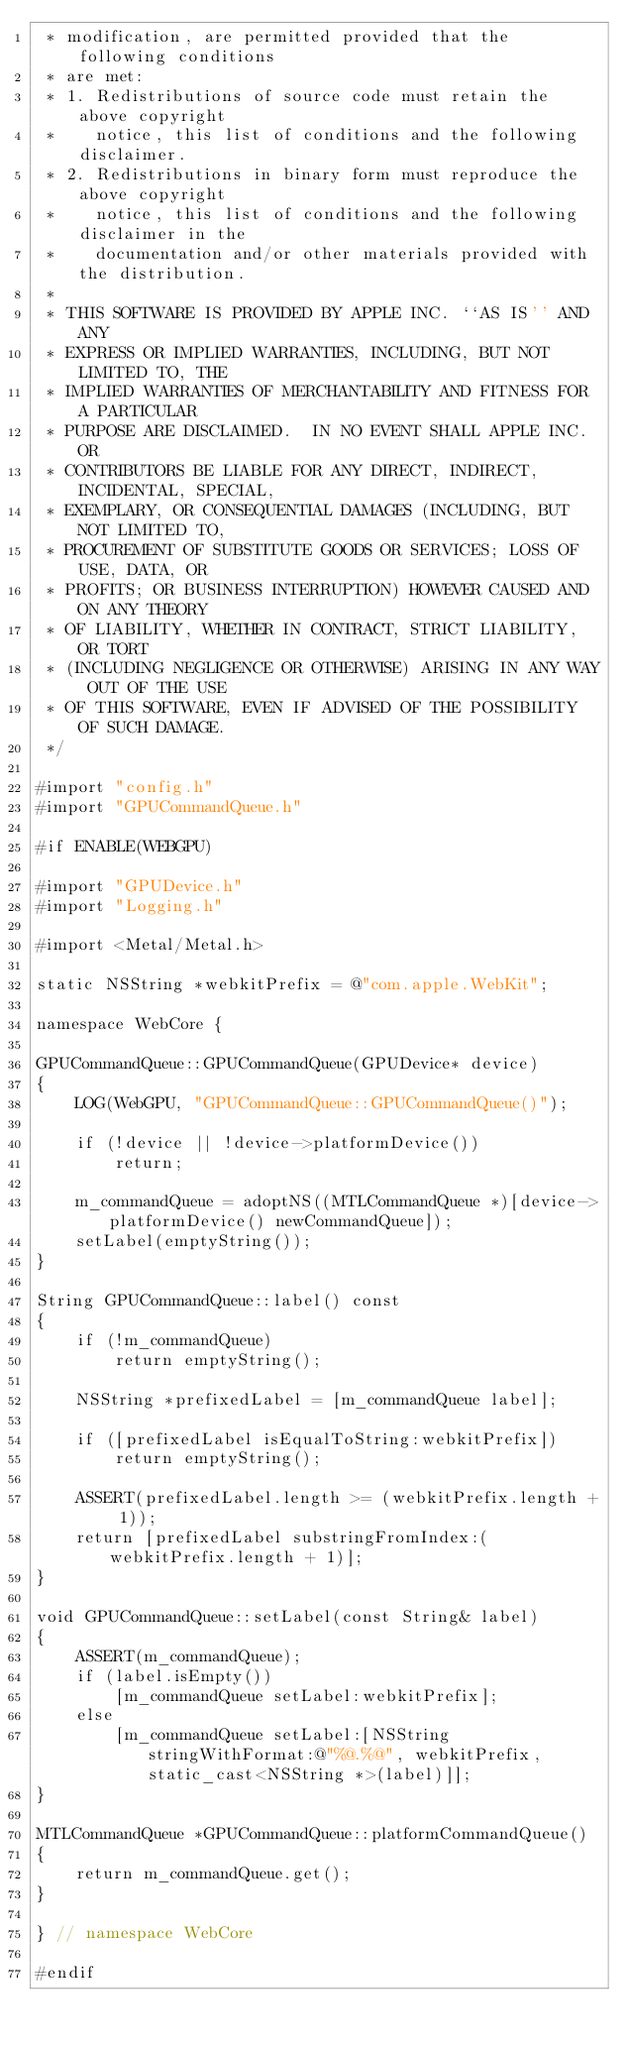<code> <loc_0><loc_0><loc_500><loc_500><_ObjectiveC_> * modification, are permitted provided that the following conditions
 * are met:
 * 1. Redistributions of source code must retain the above copyright
 *    notice, this list of conditions and the following disclaimer.
 * 2. Redistributions in binary form must reproduce the above copyright
 *    notice, this list of conditions and the following disclaimer in the
 *    documentation and/or other materials provided with the distribution.
 *
 * THIS SOFTWARE IS PROVIDED BY APPLE INC. ``AS IS'' AND ANY
 * EXPRESS OR IMPLIED WARRANTIES, INCLUDING, BUT NOT LIMITED TO, THE
 * IMPLIED WARRANTIES OF MERCHANTABILITY AND FITNESS FOR A PARTICULAR
 * PURPOSE ARE DISCLAIMED.  IN NO EVENT SHALL APPLE INC. OR
 * CONTRIBUTORS BE LIABLE FOR ANY DIRECT, INDIRECT, INCIDENTAL, SPECIAL,
 * EXEMPLARY, OR CONSEQUENTIAL DAMAGES (INCLUDING, BUT NOT LIMITED TO,
 * PROCUREMENT OF SUBSTITUTE GOODS OR SERVICES; LOSS OF USE, DATA, OR
 * PROFITS; OR BUSINESS INTERRUPTION) HOWEVER CAUSED AND ON ANY THEORY
 * OF LIABILITY, WHETHER IN CONTRACT, STRICT LIABILITY, OR TORT
 * (INCLUDING NEGLIGENCE OR OTHERWISE) ARISING IN ANY WAY OUT OF THE USE
 * OF THIS SOFTWARE, EVEN IF ADVISED OF THE POSSIBILITY OF SUCH DAMAGE.
 */

#import "config.h"
#import "GPUCommandQueue.h"

#if ENABLE(WEBGPU)

#import "GPUDevice.h"
#import "Logging.h"

#import <Metal/Metal.h>

static NSString *webkitPrefix = @"com.apple.WebKit";

namespace WebCore {

GPUCommandQueue::GPUCommandQueue(GPUDevice* device)
{
    LOG(WebGPU, "GPUCommandQueue::GPUCommandQueue()");

    if (!device || !device->platformDevice())
        return;

    m_commandQueue = adoptNS((MTLCommandQueue *)[device->platformDevice() newCommandQueue]);
    setLabel(emptyString());
}

String GPUCommandQueue::label() const
{
    if (!m_commandQueue)
        return emptyString();

    NSString *prefixedLabel = [m_commandQueue label];

    if ([prefixedLabel isEqualToString:webkitPrefix])
        return emptyString();

    ASSERT(prefixedLabel.length >= (webkitPrefix.length + 1));
    return [prefixedLabel substringFromIndex:(webkitPrefix.length + 1)];
}

void GPUCommandQueue::setLabel(const String& label)
{
    ASSERT(m_commandQueue);
    if (label.isEmpty())
        [m_commandQueue setLabel:webkitPrefix];
    else
        [m_commandQueue setLabel:[NSString stringWithFormat:@"%@.%@", webkitPrefix, static_cast<NSString *>(label)]];
}
    
MTLCommandQueue *GPUCommandQueue::platformCommandQueue()
{
    return m_commandQueue.get();
}

} // namespace WebCore

#endif
</code> 